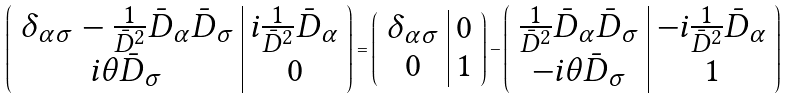<formula> <loc_0><loc_0><loc_500><loc_500>\left ( \begin{array} { c | c } \delta _ { \alpha \sigma } - \frac { 1 } { \bar { D } ^ { 2 } } \bar { D } _ { \alpha } \bar { D } _ { \sigma } & i \frac { 1 } { \bar { D } ^ { 2 } } \bar { D } _ { \alpha } \\ i \theta \bar { D } _ { \sigma } & 0 \end{array} \right ) = \left ( \begin{array} { c | c } \delta _ { \alpha \sigma } & 0 \\ 0 & 1 \end{array} \right ) - \left ( \begin{array} { c | c } \frac { 1 } { \bar { D } ^ { 2 } } \bar { D } _ { \alpha } \bar { D } _ { \sigma } & - i \frac { 1 } { \bar { D } ^ { 2 } } \bar { D } _ { \alpha } \\ - i \theta \bar { D } _ { \sigma } & 1 \end{array} \right )</formula> 